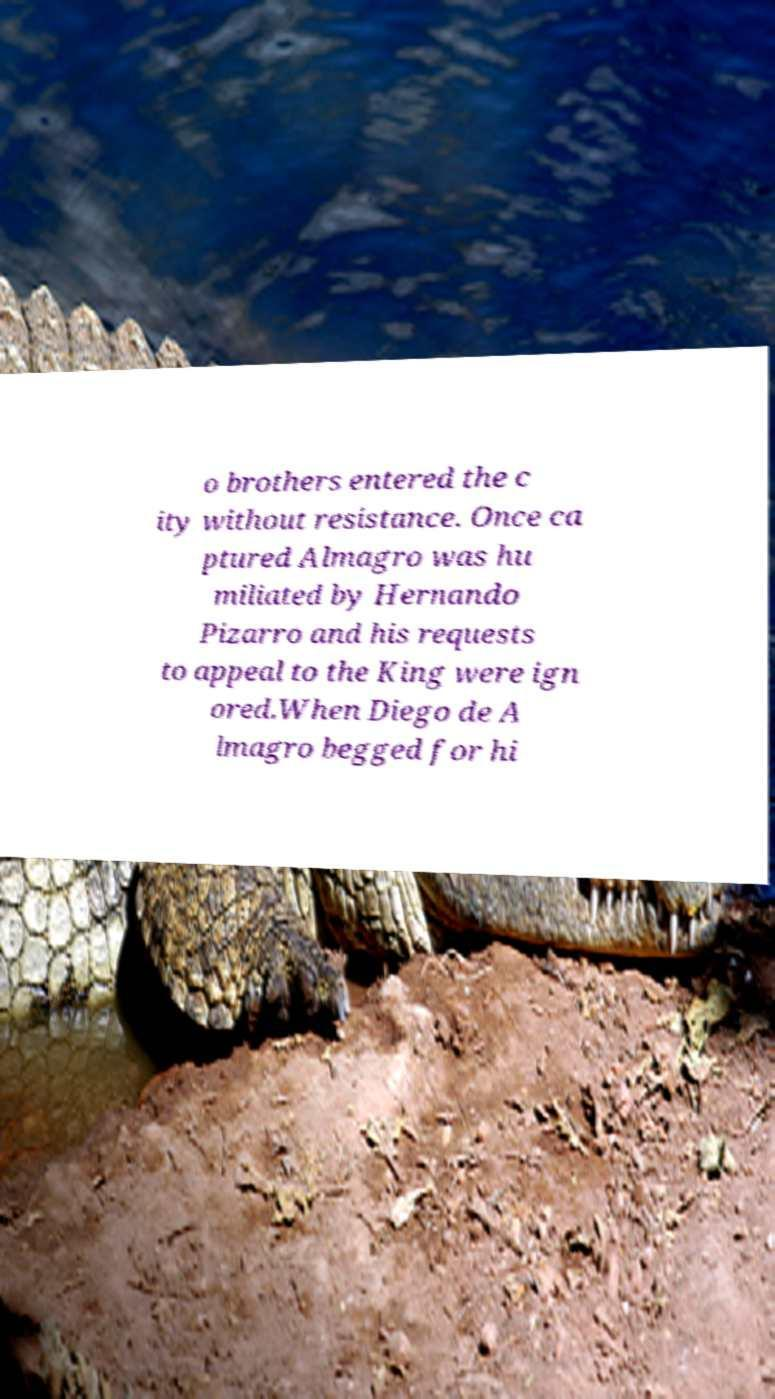Can you accurately transcribe the text from the provided image for me? o brothers entered the c ity without resistance. Once ca ptured Almagro was hu miliated by Hernando Pizarro and his requests to appeal to the King were ign ored.When Diego de A lmagro begged for hi 